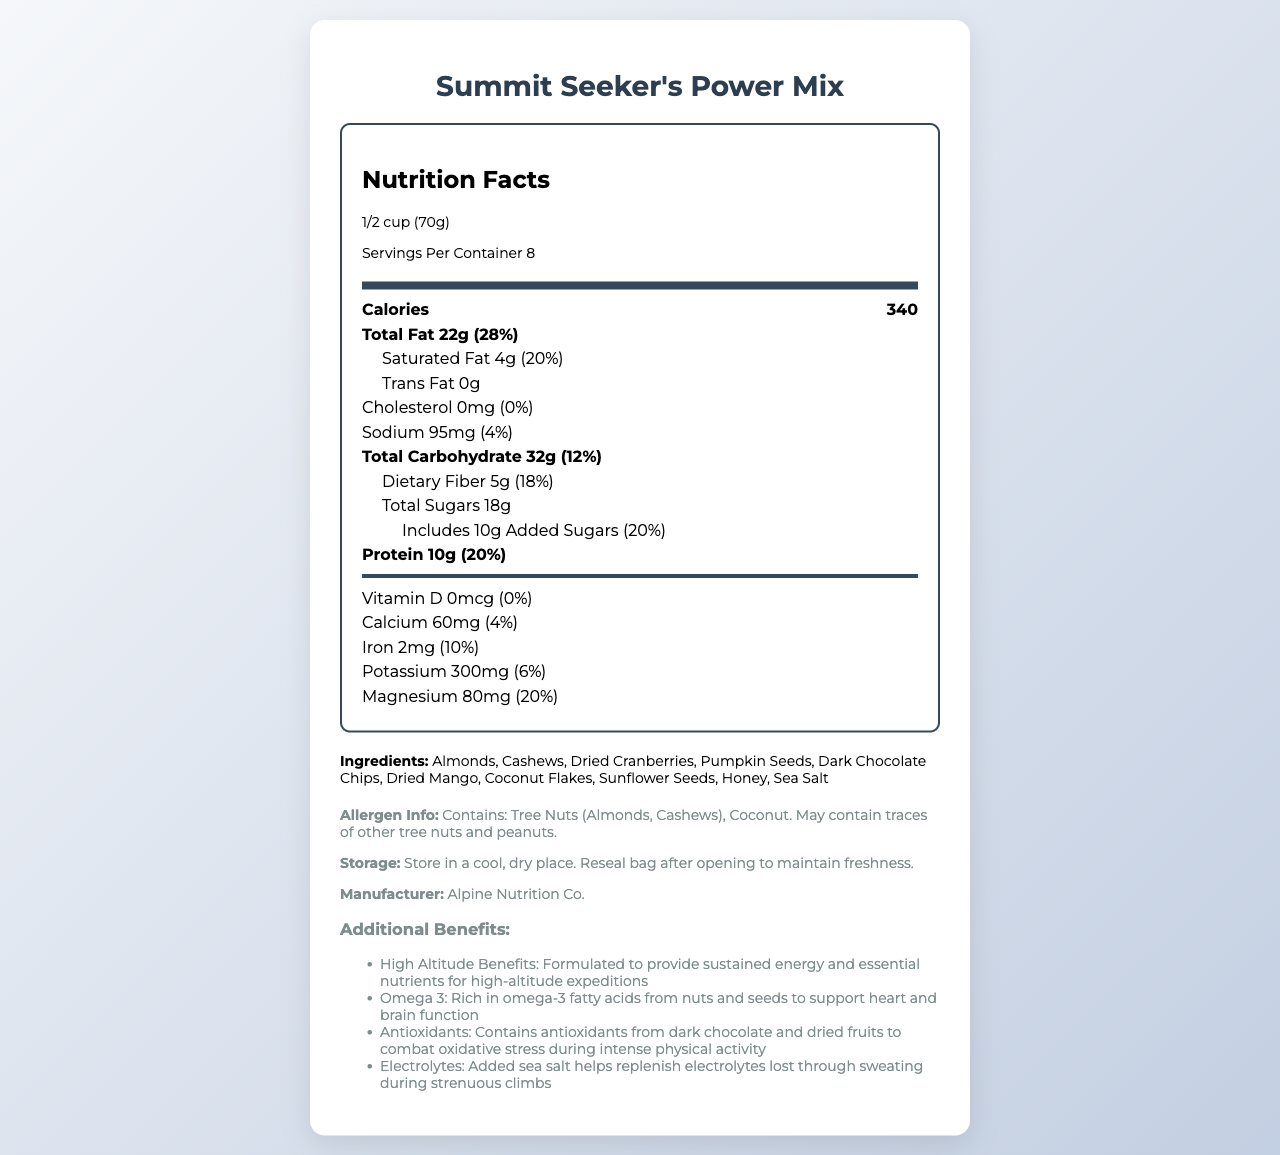what is the serving size? The document specifies that the serving size for the trail mix is 1/2 cup, which weighs 70 grams.
Answer: 1/2 cup (70g) how many servings are in one container? The document states that there are 8 servings per container.
Answer: 8 how many calories are there per serving? According to the nutrition label, each serving contains 340 calories.
Answer: 340 how much total fat does one serving contain? The total fat content per serving is listed as 22 grams.
Answer: 22g what percentage of daily value is the dietary fiber? The nutrition label shows that the dietary fiber per serving constitutes 18% of the daily value.
Answer: 18% how much protein is in one serving? The nutrition label indicates that one serving contains 10 grams of protein.
Answer: 10g what are the added sugars per serving? A. 5g B. 10g C. 15g D. 20g The document states that there are 10 grams of added sugars per serving, which is 20% of the daily value.
Answer: B. 10g which vitamin or mineral has the highest daily value percentage? A. Calcium B. Iron C. Potassium D. Magnesium The document shows magnesium has a daily value percentage of 20%, which is higher than the other listed vitamins and minerals.
Answer: D. Magnesium is this product cholesterol-free? The nutrition facts label indicates that the cholesterol amount is 0mg, meaning it is cholesterol-free.
Answer: Yes what allergens does the product contain? The allergen info section mentions that the product contains tree nuts and coconut.
Answer: Tree nuts (Almonds, Cashews), Coconut describe the main benefits of the product according to the additional information section. The additional information section highlights these key benefits, emphasizing the product's suitability for high-altitude activities and overall health support during intense physical exertion.
Answer: The main benefits include providing sustained energy and essential nutrients for high-altitude expeditions, being rich in omega-3 fatty acids to support heart and brain function, containing antioxidants to combat oxidative stress, and having added sea salt to replenish electrolytes lost during strenuous climbs. how much calcium is in one serving? The vitamins and minerals section lists calcium content as 60 milligrams per serving.
Answer: 60mg is there any vitamin D in the product? The nutrition facts label indicates that there is 0mcg of Vitamin D in the product.
Answer: No what is the dietary fiber content of the product? A. 3g B. 4g C. 5g D. 6g The nutrition facts specify that there are 5 grams of dietary fiber per serving, which accounts for 18% of the daily value.
Answer: C. 5g what is the manufacturer's name? The document states that Alpine Nutrition Co. is the manufacturer.
Answer: Alpine Nutrition Co. what are the storage instructions for the product? The storage instructions are provided clearly at the end of the document, advising on how to keep the product fresh.
Answer: Store in a cool, dry place. Reseal bag after opening to maintain freshness. explain the high-altitude benefits of the product. The additional information section under "high altitude benefits" specifies that the product is designed to meet the energy and nutrient needs of high-altitude activities.
Answer: The trail mix is formulated to provide sustained energy and essential nutrients required for high-altitude expeditions, making it particularly suitable for mountain climbers and similar activities. does the product contain honey as an ingredient? Honey is listed among the ingredients in the document.
Answer: Yes can you find the expiration date of the product? The expiration date is not provided in the document, so it cannot be determined from the given visual information.
Answer: Not enough information 